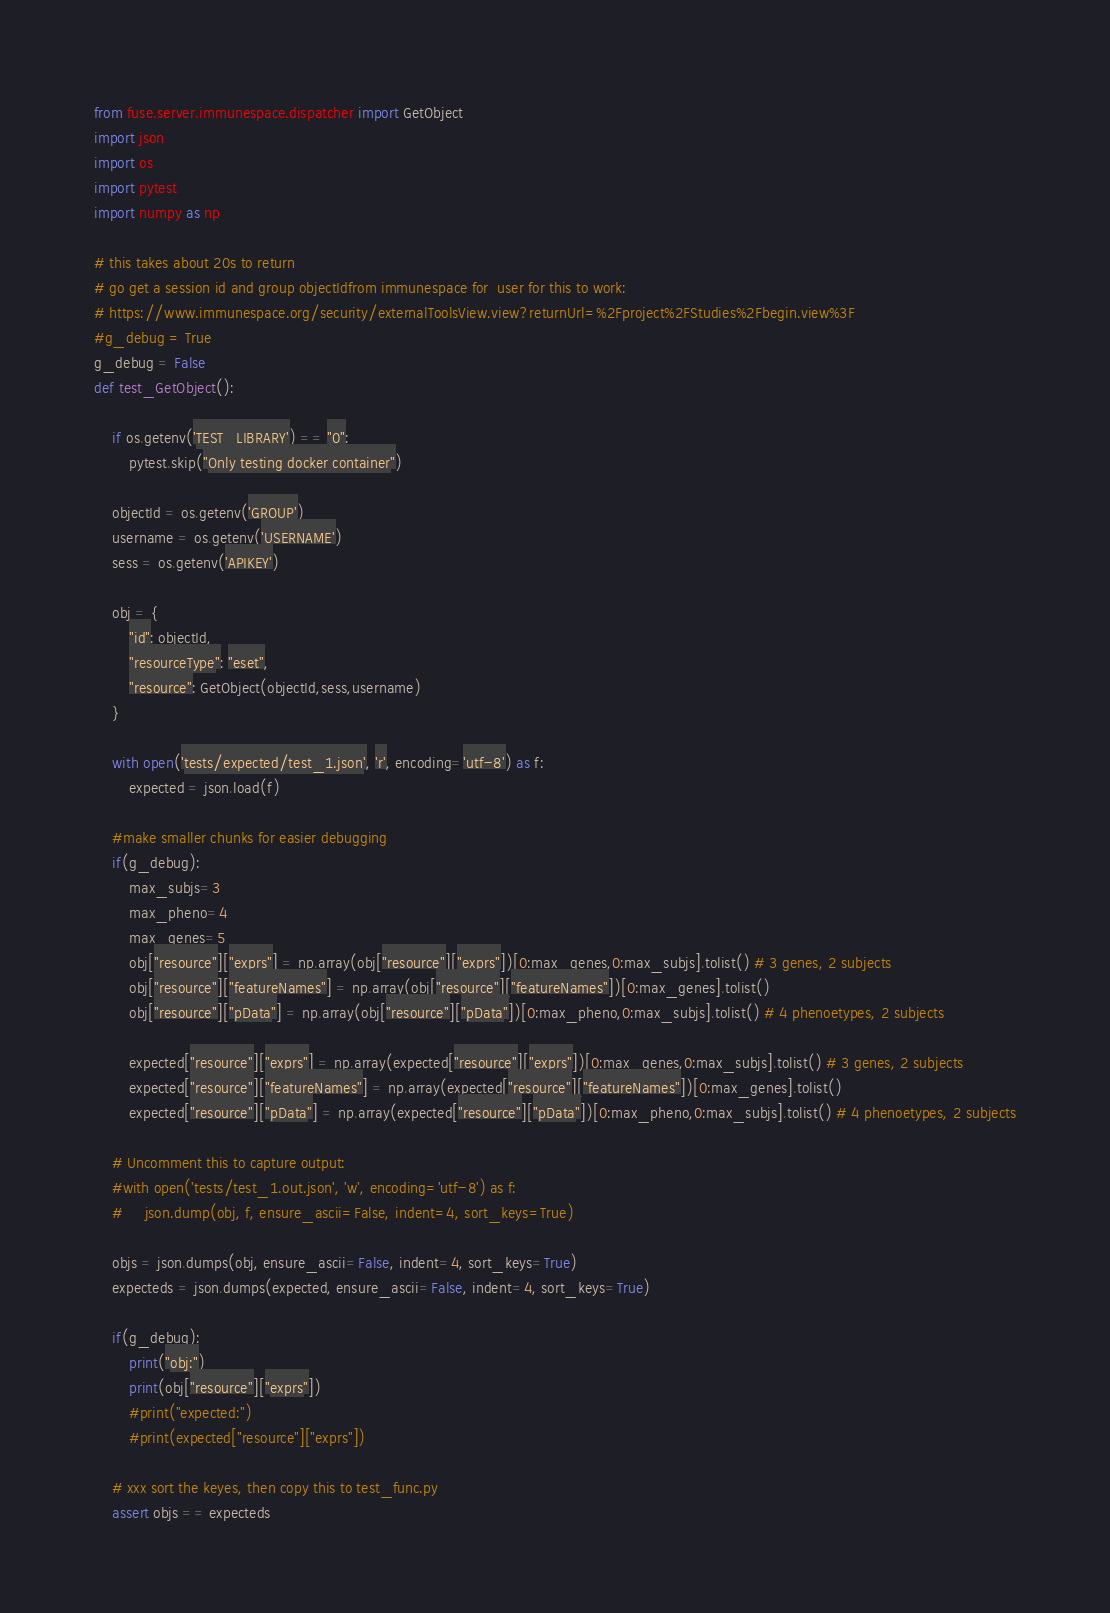<code> <loc_0><loc_0><loc_500><loc_500><_Python_>from fuse.server.immunespace.dispatcher import GetObject
import json
import os
import pytest
import numpy as np

# this takes about 20s to return
# go get a session id and group objectIdfrom immunespace for  user for this to work:
# https://www.immunespace.org/security/externalToolsView.view?returnUrl=%2Fproject%2FStudies%2Fbegin.view%3F
#g_debug = True
g_debug = False
def test_GetObject():

    if os.getenv('TEST_LIBRARY') == "0":
        pytest.skip("Only testing docker container")

    objectId = os.getenv('GROUP')
    username = os.getenv('USERNAME')
    sess = os.getenv('APIKEY')

    obj = {
        "id": objectId,
        "resourceType": "eset",
        "resource": GetObject(objectId,sess,username)
    }

    with open('tests/expected/test_1.json', 'r', encoding='utf-8') as f:
        expected = json.load(f)

    #make smaller chunks for easier debugging
    if(g_debug):
        max_subjs=3
        max_pheno=4
        max_genes=5
        obj["resource"]["exprs"] = np.array(obj["resource"]["exprs"])[0:max_genes,0:max_subjs].tolist() # 3 genes, 2 subjects
        obj["resource"]["featureNames"] = np.array(obj["resource"]["featureNames"])[0:max_genes].tolist()
        obj["resource"]["pData"] = np.array(obj["resource"]["pData"])[0:max_pheno,0:max_subjs].tolist() # 4 phenoetypes, 2 subjects
        
        expected["resource"]["exprs"] = np.array(expected["resource"]["exprs"])[0:max_genes,0:max_subjs].tolist() # 3 genes, 2 subjects
        expected["resource"]["featureNames"] = np.array(expected["resource"]["featureNames"])[0:max_genes].tolist()
        expected["resource"]["pData"] = np.array(expected["resource"]["pData"])[0:max_pheno,0:max_subjs].tolist() # 4 phenoetypes, 2 subjects
        
    # Uncomment this to capture output:
    #with open('tests/test_1.out.json', 'w', encoding='utf-8') as f:
    #     json.dump(obj, f, ensure_ascii=False, indent=4, sort_keys=True)

    objs = json.dumps(obj, ensure_ascii=False, indent=4, sort_keys=True)
    expecteds = json.dumps(expected, ensure_ascii=False, indent=4, sort_keys=True)

    if(g_debug):
        print("obj:")
        print(obj["resource"]["exprs"])
        #print("expected:")
        #print(expected["resource"]["exprs"])
        
    # xxx sort the keyes, then copy this to test_func.py
    assert objs == expecteds

</code> 